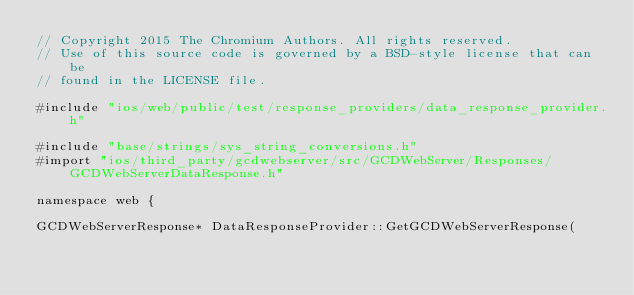Convert code to text. <code><loc_0><loc_0><loc_500><loc_500><_ObjectiveC_>// Copyright 2015 The Chromium Authors. All rights reserved.
// Use of this source code is governed by a BSD-style license that can be
// found in the LICENSE file.

#include "ios/web/public/test/response_providers/data_response_provider.h"

#include "base/strings/sys_string_conversions.h"
#import "ios/third_party/gcdwebserver/src/GCDWebServer/Responses/GCDWebServerDataResponse.h"

namespace web {

GCDWebServerResponse* DataResponseProvider::GetGCDWebServerResponse(</code> 